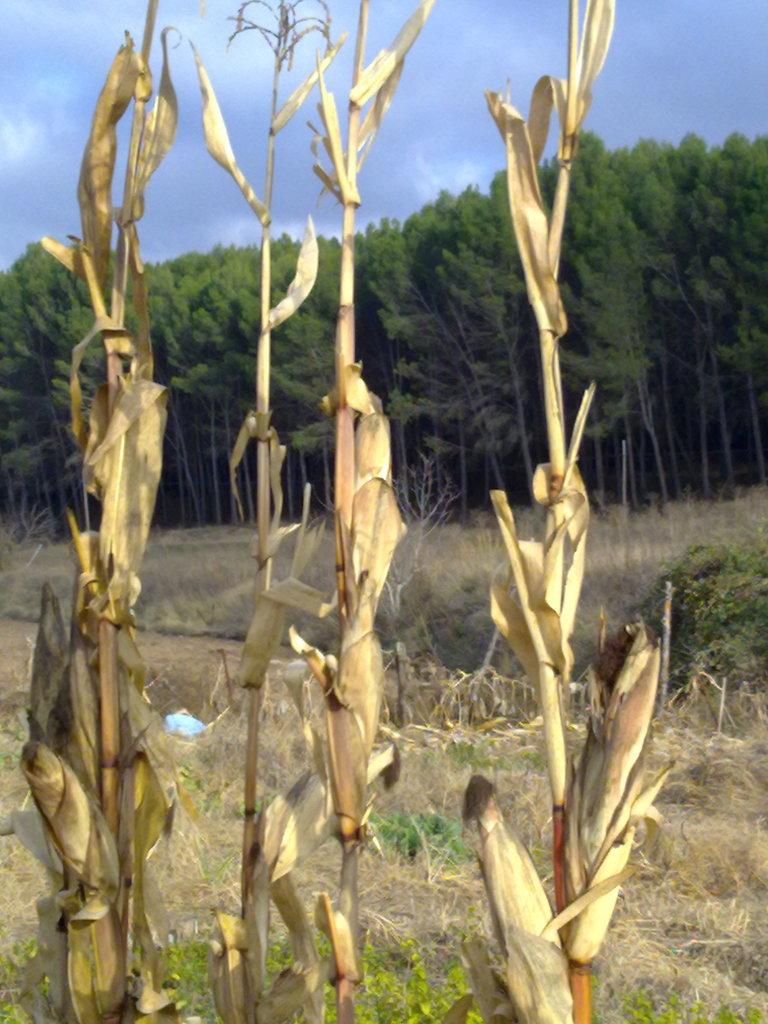What is the main subject in the center of the image? There are plants in the center of the image. What can be seen in the background of the image? There are trees in the background of the image. What type of vegetation covers the ground at the bottom of the image? The ground is covered with grass at the bottom of the image. What is visible at the top of the image? The sky is visible at the top of the image. What caption is written on the image? There is no caption present in the image. What show is being advertised in the image? There is no show being advertised in the image; it features plants, trees, grass, and the sky. 